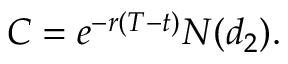<formula> <loc_0><loc_0><loc_500><loc_500>C = e ^ { - r ( T - t ) } N ( d _ { 2 } ) .</formula> 